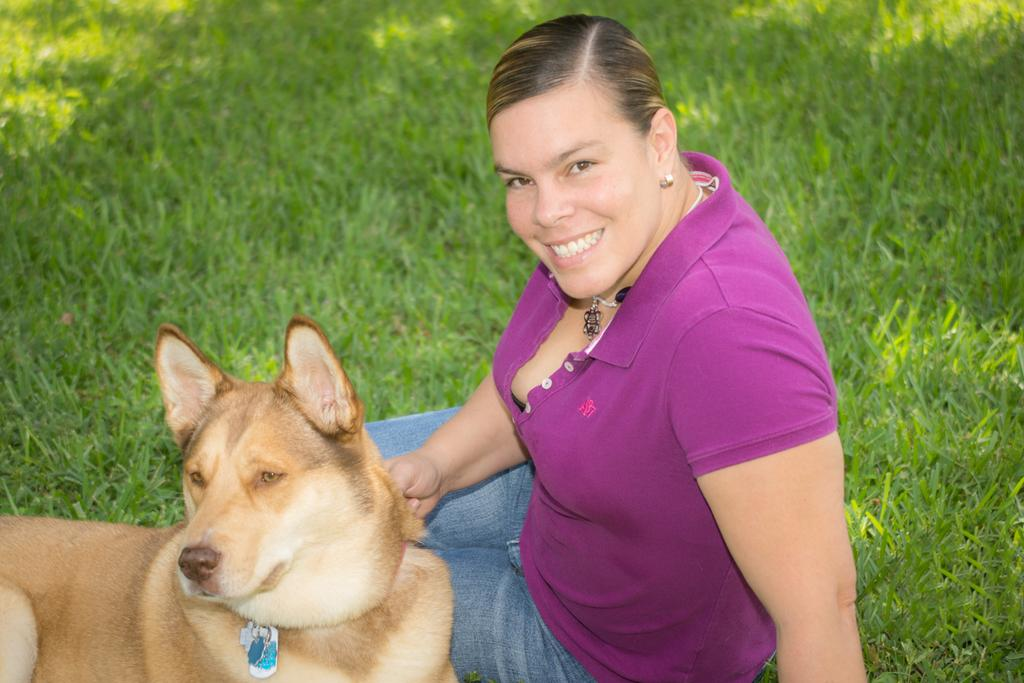Who is the main subject in the image? There is a lady in the image. What is the lady wearing in the image? The lady is wearing a violet t-shirt and jeans. Where is the lady sitting in the image? The lady is sitting on grass. What animal is present beside the lady in the image? There is a dog beside the lady. What type of comfort can be seen in the image? There is no specific type of comfort visible in the image. What type of baseball equipment can be seen in the image? There is no baseball equipment present in the image. What type of sky is visible in the image? The provided facts do not mention the sky, so it cannot be determined from the image. 